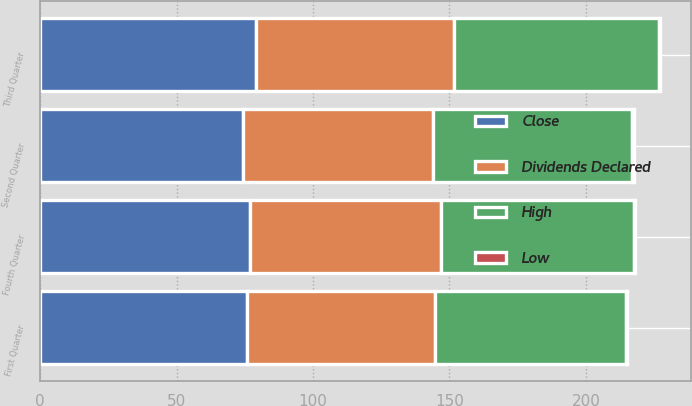Convert chart to OTSL. <chart><loc_0><loc_0><loc_500><loc_500><stacked_bar_chart><ecel><fcel>First Quarter<fcel>Second Quarter<fcel>Third Quarter<fcel>Fourth Quarter<nl><fcel>Close<fcel>75.98<fcel>74.48<fcel>78.99<fcel>77<nl><fcel>Dividends Declared<fcel>68.66<fcel>69.54<fcel>72.7<fcel>70<nl><fcel>High<fcel>70.1<fcel>73<fcel>75.1<fcel>70.72<nl><fcel>Low<fcel>0.42<fcel>0.42<fcel>0.42<fcel>0.42<nl></chart> 